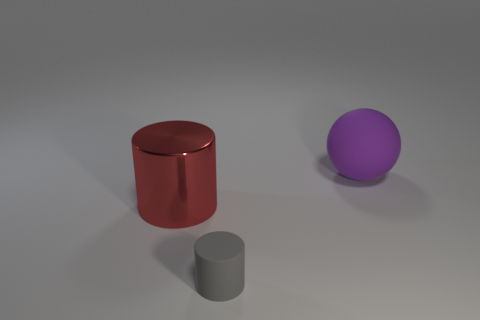Are any gray objects visible?
Your answer should be compact. Yes. What number of things are matte things that are in front of the metallic cylinder or rubber objects?
Provide a short and direct response. 2. Is the color of the metallic cylinder the same as the matte thing that is in front of the purple sphere?
Your response must be concise. No. Are there any gray rubber objects of the same size as the shiny object?
Give a very brief answer. No. What material is the big purple thing to the right of the cylinder behind the small gray thing?
Give a very brief answer. Rubber. What number of other tiny cylinders are the same color as the small cylinder?
Your response must be concise. 0. What is the shape of the thing that is made of the same material as the gray cylinder?
Your answer should be very brief. Sphere. There is a cylinder left of the small gray rubber thing; what is its size?
Keep it short and to the point. Large. Are there an equal number of big purple rubber balls that are to the left of the shiny cylinder and gray matte cylinders left of the small rubber cylinder?
Give a very brief answer. Yes. What is the color of the cylinder behind the matte object that is in front of the cylinder that is behind the tiny gray matte cylinder?
Keep it short and to the point. Red. 